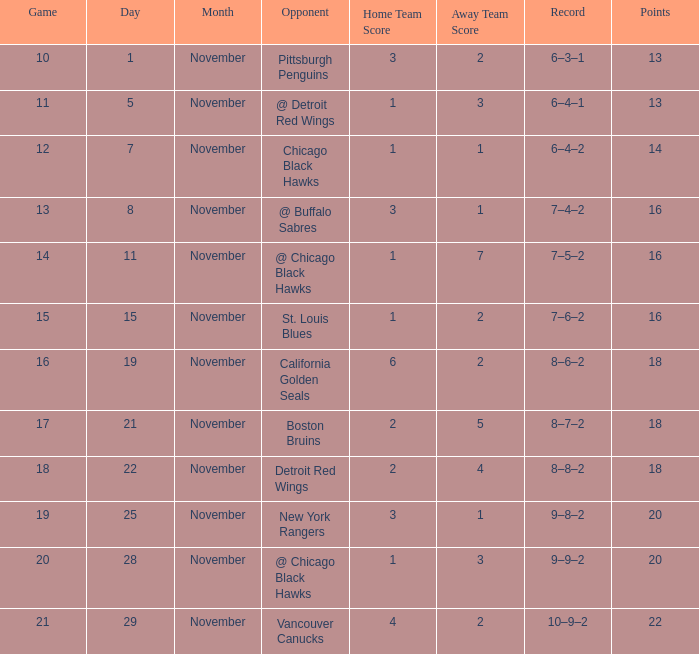What is the highest November that has a game less than 12, and @ detroit red wings as the opponent? 5.0. 